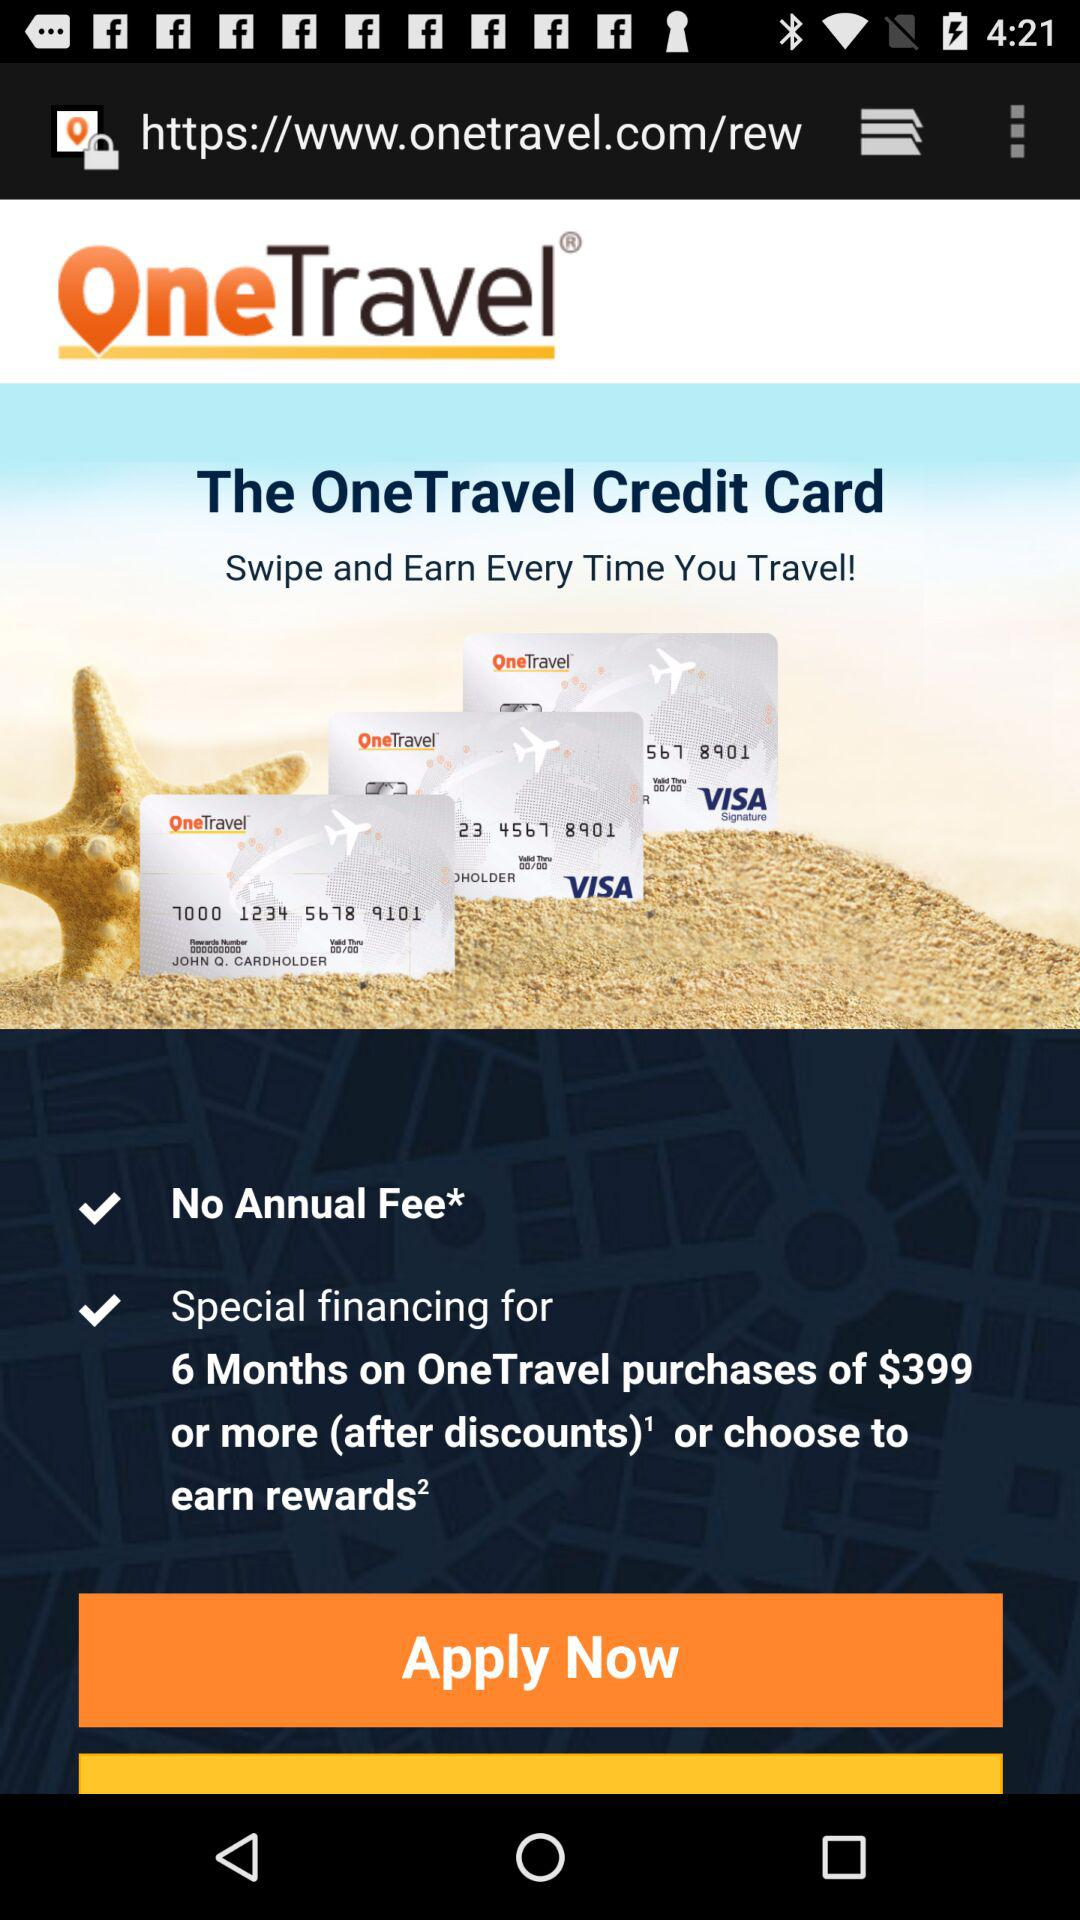How many check marks are there on the screen?
Answer the question using a single word or phrase. 2 